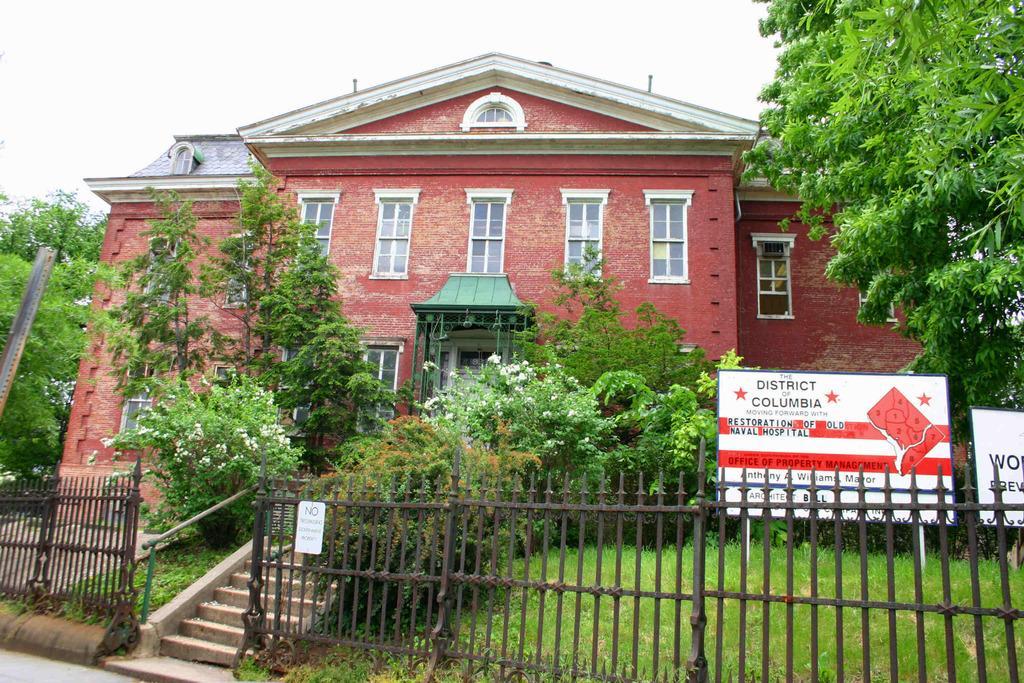In one or two sentences, can you explain what this image depicts? In this image I can see the rail. I can see the grass and trees. On the right side, I can see a board with some written text on it. In the background, I can see the house. 